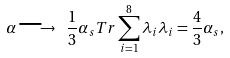<formula> <loc_0><loc_0><loc_500><loc_500>\alpha \longrightarrow \ \frac { 1 } { 3 } \alpha _ { s } T r \sum _ { i = 1 } ^ { 8 } \lambda _ { i } \lambda _ { i } = \frac { 4 } { 3 } \alpha _ { s } ,</formula> 